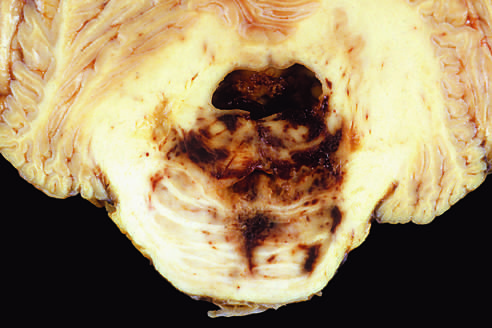does cd15 displace the brain downward?
Answer the question using a single word or phrase. No 